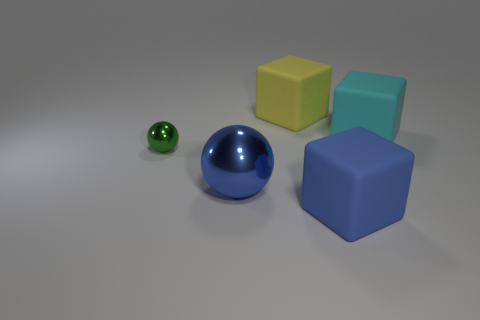What number of things are either balls that are in front of the green shiny ball or objects that are behind the blue cube?
Ensure brevity in your answer.  4. The large blue thing on the right side of the object behind the cyan thing is what shape?
Provide a short and direct response. Cube. Are there any yellow blocks that have the same material as the large cyan cube?
Make the answer very short. Yes. What is the color of the other small metal object that is the same shape as the blue shiny thing?
Offer a terse response. Green. Is the number of rubber things in front of the yellow cube less than the number of small metal balls that are on the right side of the large blue matte cube?
Provide a succinct answer. No. What number of other things are the same shape as the cyan thing?
Make the answer very short. 2. Are there fewer big rubber things in front of the tiny green metallic ball than big green metallic cylinders?
Offer a terse response. No. There is a tiny sphere in front of the cyan block; what material is it?
Give a very brief answer. Metal. What number of other things are there of the same size as the yellow block?
Your answer should be very brief. 3. Is the number of large shiny things less than the number of large blue objects?
Your response must be concise. Yes. 